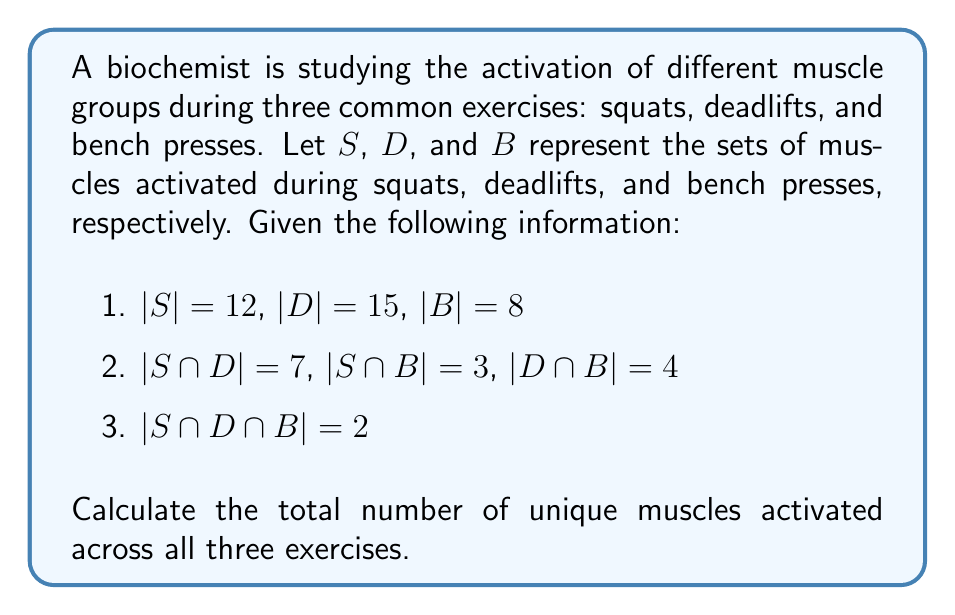Help me with this question. To solve this problem, we can use the principle of inclusion-exclusion for three sets. The formula for the union of three sets is:

$$|S \cup D \cup B| = |S| + |D| + |B| - |S \cap D| - |S \cap B| - |D \cap B| + |S \cap D \cap B|$$

Let's substitute the given values:

1. $|S| = 12$, $|D| = 15$, $|B| = 8$
2. $|S \cap D| = 7$, $|S \cap B| = 3$, $|D \cap B| = 4$
3. $|S \cap D \cap B| = 2$

Now, let's calculate:

$$\begin{align*}
|S \cup D \cup B| &= 12 + 15 + 8 - 7 - 3 - 4 + 2 \\
&= 35 - 14 + 2 \\
&= 23
\end{align*}$$

Therefore, the total number of unique muscles activated across all three exercises is 23.
Answer: 23 unique muscles 